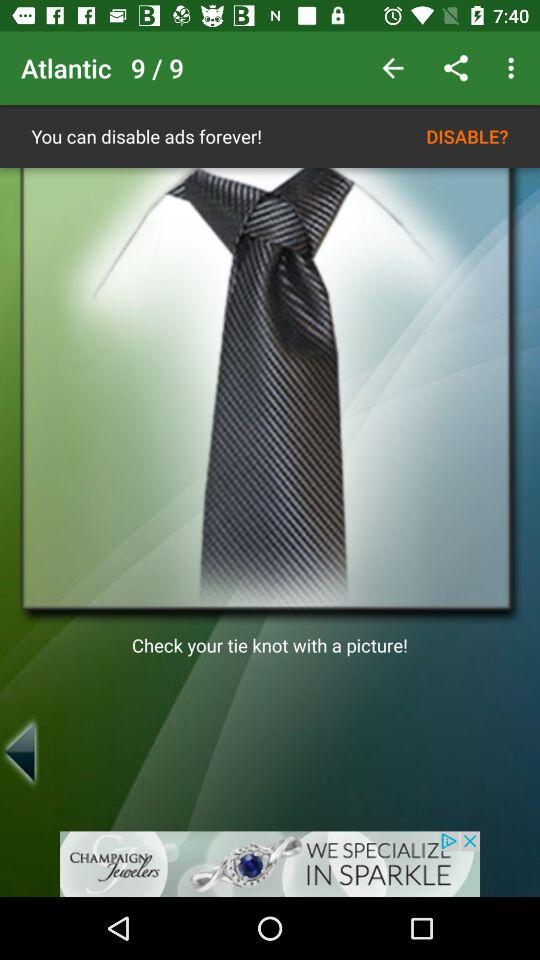What is the total number of slides? The total number of slides is 9. 